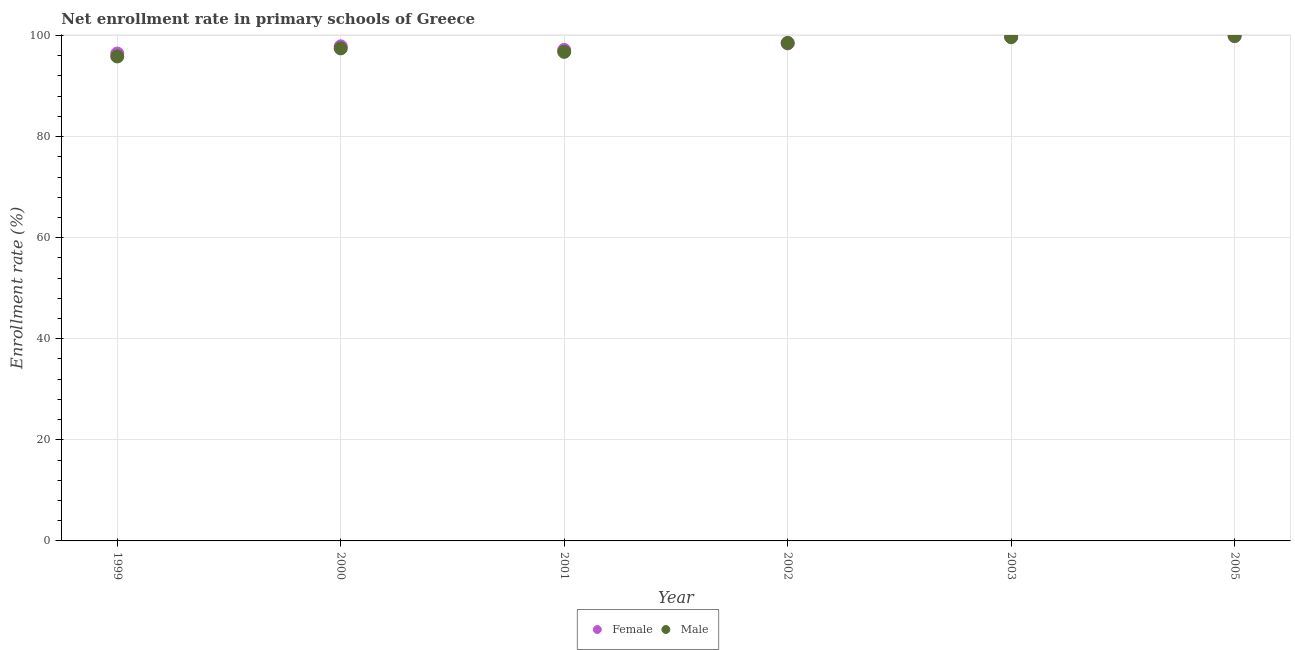Is the number of dotlines equal to the number of legend labels?
Offer a very short reply. Yes. What is the enrollment rate of female students in 2002?
Your answer should be very brief. 98.45. Across all years, what is the maximum enrollment rate of female students?
Offer a very short reply. 99.88. Across all years, what is the minimum enrollment rate of female students?
Offer a very short reply. 96.44. In which year was the enrollment rate of male students minimum?
Give a very brief answer. 1999. What is the total enrollment rate of male students in the graph?
Your answer should be very brief. 588.23. What is the difference between the enrollment rate of male students in 1999 and that in 2001?
Your answer should be very brief. -0.91. What is the difference between the enrollment rate of male students in 1999 and the enrollment rate of female students in 2002?
Offer a very short reply. -2.59. What is the average enrollment rate of male students per year?
Offer a very short reply. 98.04. In the year 2000, what is the difference between the enrollment rate of male students and enrollment rate of female students?
Your answer should be very brief. -0.41. In how many years, is the enrollment rate of female students greater than 32 %?
Ensure brevity in your answer.  6. What is the ratio of the enrollment rate of female students in 1999 to that in 2005?
Offer a terse response. 0.97. Is the enrollment rate of female students in 2001 less than that in 2005?
Ensure brevity in your answer.  Yes. What is the difference between the highest and the second highest enrollment rate of female students?
Make the answer very short. 0.11. What is the difference between the highest and the lowest enrollment rate of female students?
Give a very brief answer. 3.44. Is the enrollment rate of male students strictly greater than the enrollment rate of female students over the years?
Make the answer very short. No. Is the enrollment rate of male students strictly less than the enrollment rate of female students over the years?
Offer a very short reply. No. Does the graph contain grids?
Make the answer very short. Yes. Where does the legend appear in the graph?
Offer a very short reply. Bottom center. How are the legend labels stacked?
Offer a terse response. Horizontal. What is the title of the graph?
Ensure brevity in your answer.  Net enrollment rate in primary schools of Greece. What is the label or title of the X-axis?
Your answer should be very brief. Year. What is the label or title of the Y-axis?
Offer a terse response. Enrollment rate (%). What is the Enrollment rate (%) in Female in 1999?
Keep it short and to the point. 96.44. What is the Enrollment rate (%) in Male in 1999?
Your answer should be very brief. 95.86. What is the Enrollment rate (%) of Female in 2000?
Your answer should be very brief. 97.86. What is the Enrollment rate (%) of Male in 2000?
Keep it short and to the point. 97.46. What is the Enrollment rate (%) of Female in 2001?
Offer a very short reply. 97.15. What is the Enrollment rate (%) in Male in 2001?
Give a very brief answer. 96.77. What is the Enrollment rate (%) of Female in 2002?
Offer a terse response. 98.45. What is the Enrollment rate (%) in Male in 2002?
Make the answer very short. 98.54. What is the Enrollment rate (%) of Female in 2003?
Provide a short and direct response. 99.77. What is the Enrollment rate (%) of Male in 2003?
Give a very brief answer. 99.67. What is the Enrollment rate (%) of Female in 2005?
Offer a very short reply. 99.88. What is the Enrollment rate (%) in Male in 2005?
Your response must be concise. 99.93. Across all years, what is the maximum Enrollment rate (%) in Female?
Your answer should be compact. 99.88. Across all years, what is the maximum Enrollment rate (%) of Male?
Your response must be concise. 99.93. Across all years, what is the minimum Enrollment rate (%) in Female?
Your response must be concise. 96.44. Across all years, what is the minimum Enrollment rate (%) in Male?
Offer a terse response. 95.86. What is the total Enrollment rate (%) in Female in the graph?
Ensure brevity in your answer.  589.54. What is the total Enrollment rate (%) of Male in the graph?
Offer a terse response. 588.23. What is the difference between the Enrollment rate (%) of Female in 1999 and that in 2000?
Keep it short and to the point. -1.43. What is the difference between the Enrollment rate (%) of Male in 1999 and that in 2000?
Provide a succinct answer. -1.6. What is the difference between the Enrollment rate (%) in Female in 1999 and that in 2001?
Provide a succinct answer. -0.72. What is the difference between the Enrollment rate (%) in Male in 1999 and that in 2001?
Your response must be concise. -0.91. What is the difference between the Enrollment rate (%) in Female in 1999 and that in 2002?
Keep it short and to the point. -2.01. What is the difference between the Enrollment rate (%) of Male in 1999 and that in 2002?
Offer a terse response. -2.68. What is the difference between the Enrollment rate (%) of Female in 1999 and that in 2003?
Your answer should be compact. -3.33. What is the difference between the Enrollment rate (%) of Male in 1999 and that in 2003?
Your answer should be compact. -3.81. What is the difference between the Enrollment rate (%) of Female in 1999 and that in 2005?
Your answer should be very brief. -3.44. What is the difference between the Enrollment rate (%) of Male in 1999 and that in 2005?
Your answer should be very brief. -4.07. What is the difference between the Enrollment rate (%) of Female in 2000 and that in 2001?
Offer a terse response. 0.71. What is the difference between the Enrollment rate (%) of Male in 2000 and that in 2001?
Ensure brevity in your answer.  0.69. What is the difference between the Enrollment rate (%) of Female in 2000 and that in 2002?
Provide a short and direct response. -0.58. What is the difference between the Enrollment rate (%) of Male in 2000 and that in 2002?
Keep it short and to the point. -1.09. What is the difference between the Enrollment rate (%) in Female in 2000 and that in 2003?
Offer a very short reply. -1.91. What is the difference between the Enrollment rate (%) in Male in 2000 and that in 2003?
Offer a very short reply. -2.21. What is the difference between the Enrollment rate (%) in Female in 2000 and that in 2005?
Ensure brevity in your answer.  -2.01. What is the difference between the Enrollment rate (%) in Male in 2000 and that in 2005?
Keep it short and to the point. -2.47. What is the difference between the Enrollment rate (%) of Female in 2001 and that in 2002?
Keep it short and to the point. -1.3. What is the difference between the Enrollment rate (%) of Male in 2001 and that in 2002?
Your response must be concise. -1.77. What is the difference between the Enrollment rate (%) in Female in 2001 and that in 2003?
Provide a succinct answer. -2.62. What is the difference between the Enrollment rate (%) of Male in 2001 and that in 2003?
Provide a succinct answer. -2.9. What is the difference between the Enrollment rate (%) in Female in 2001 and that in 2005?
Give a very brief answer. -2.72. What is the difference between the Enrollment rate (%) of Male in 2001 and that in 2005?
Your answer should be very brief. -3.16. What is the difference between the Enrollment rate (%) of Female in 2002 and that in 2003?
Provide a short and direct response. -1.32. What is the difference between the Enrollment rate (%) of Male in 2002 and that in 2003?
Keep it short and to the point. -1.13. What is the difference between the Enrollment rate (%) in Female in 2002 and that in 2005?
Your response must be concise. -1.43. What is the difference between the Enrollment rate (%) of Male in 2002 and that in 2005?
Offer a very short reply. -1.38. What is the difference between the Enrollment rate (%) of Female in 2003 and that in 2005?
Offer a terse response. -0.11. What is the difference between the Enrollment rate (%) in Male in 2003 and that in 2005?
Make the answer very short. -0.26. What is the difference between the Enrollment rate (%) in Female in 1999 and the Enrollment rate (%) in Male in 2000?
Ensure brevity in your answer.  -1.02. What is the difference between the Enrollment rate (%) in Female in 1999 and the Enrollment rate (%) in Male in 2001?
Offer a very short reply. -0.34. What is the difference between the Enrollment rate (%) of Female in 1999 and the Enrollment rate (%) of Male in 2002?
Provide a short and direct response. -2.11. What is the difference between the Enrollment rate (%) in Female in 1999 and the Enrollment rate (%) in Male in 2003?
Offer a very short reply. -3.24. What is the difference between the Enrollment rate (%) of Female in 1999 and the Enrollment rate (%) of Male in 2005?
Provide a succinct answer. -3.49. What is the difference between the Enrollment rate (%) of Female in 2000 and the Enrollment rate (%) of Male in 2001?
Provide a succinct answer. 1.09. What is the difference between the Enrollment rate (%) in Female in 2000 and the Enrollment rate (%) in Male in 2002?
Your answer should be compact. -0.68. What is the difference between the Enrollment rate (%) in Female in 2000 and the Enrollment rate (%) in Male in 2003?
Ensure brevity in your answer.  -1.81. What is the difference between the Enrollment rate (%) in Female in 2000 and the Enrollment rate (%) in Male in 2005?
Provide a short and direct response. -2.06. What is the difference between the Enrollment rate (%) of Female in 2001 and the Enrollment rate (%) of Male in 2002?
Provide a succinct answer. -1.39. What is the difference between the Enrollment rate (%) of Female in 2001 and the Enrollment rate (%) of Male in 2003?
Keep it short and to the point. -2.52. What is the difference between the Enrollment rate (%) of Female in 2001 and the Enrollment rate (%) of Male in 2005?
Make the answer very short. -2.77. What is the difference between the Enrollment rate (%) of Female in 2002 and the Enrollment rate (%) of Male in 2003?
Give a very brief answer. -1.22. What is the difference between the Enrollment rate (%) of Female in 2002 and the Enrollment rate (%) of Male in 2005?
Provide a short and direct response. -1.48. What is the difference between the Enrollment rate (%) of Female in 2003 and the Enrollment rate (%) of Male in 2005?
Offer a very short reply. -0.16. What is the average Enrollment rate (%) in Female per year?
Provide a succinct answer. 98.26. What is the average Enrollment rate (%) in Male per year?
Offer a terse response. 98.04. In the year 1999, what is the difference between the Enrollment rate (%) in Female and Enrollment rate (%) in Male?
Provide a short and direct response. 0.57. In the year 2000, what is the difference between the Enrollment rate (%) in Female and Enrollment rate (%) in Male?
Make the answer very short. 0.41. In the year 2001, what is the difference between the Enrollment rate (%) in Female and Enrollment rate (%) in Male?
Make the answer very short. 0.38. In the year 2002, what is the difference between the Enrollment rate (%) of Female and Enrollment rate (%) of Male?
Your answer should be compact. -0.1. In the year 2003, what is the difference between the Enrollment rate (%) of Female and Enrollment rate (%) of Male?
Your response must be concise. 0.1. In the year 2005, what is the difference between the Enrollment rate (%) of Female and Enrollment rate (%) of Male?
Offer a terse response. -0.05. What is the ratio of the Enrollment rate (%) in Female in 1999 to that in 2000?
Offer a terse response. 0.99. What is the ratio of the Enrollment rate (%) of Male in 1999 to that in 2000?
Offer a terse response. 0.98. What is the ratio of the Enrollment rate (%) of Male in 1999 to that in 2001?
Keep it short and to the point. 0.99. What is the ratio of the Enrollment rate (%) of Female in 1999 to that in 2002?
Keep it short and to the point. 0.98. What is the ratio of the Enrollment rate (%) of Male in 1999 to that in 2002?
Provide a succinct answer. 0.97. What is the ratio of the Enrollment rate (%) of Female in 1999 to that in 2003?
Your answer should be compact. 0.97. What is the ratio of the Enrollment rate (%) in Male in 1999 to that in 2003?
Your response must be concise. 0.96. What is the ratio of the Enrollment rate (%) of Female in 1999 to that in 2005?
Provide a short and direct response. 0.97. What is the ratio of the Enrollment rate (%) in Male in 1999 to that in 2005?
Make the answer very short. 0.96. What is the ratio of the Enrollment rate (%) of Female in 2000 to that in 2001?
Your response must be concise. 1.01. What is the ratio of the Enrollment rate (%) of Male in 2000 to that in 2001?
Ensure brevity in your answer.  1.01. What is the ratio of the Enrollment rate (%) of Female in 2000 to that in 2002?
Make the answer very short. 0.99. What is the ratio of the Enrollment rate (%) of Male in 2000 to that in 2002?
Your response must be concise. 0.99. What is the ratio of the Enrollment rate (%) in Female in 2000 to that in 2003?
Ensure brevity in your answer.  0.98. What is the ratio of the Enrollment rate (%) of Male in 2000 to that in 2003?
Offer a terse response. 0.98. What is the ratio of the Enrollment rate (%) in Female in 2000 to that in 2005?
Your response must be concise. 0.98. What is the ratio of the Enrollment rate (%) of Male in 2000 to that in 2005?
Ensure brevity in your answer.  0.98. What is the ratio of the Enrollment rate (%) in Female in 2001 to that in 2003?
Your response must be concise. 0.97. What is the ratio of the Enrollment rate (%) of Male in 2001 to that in 2003?
Your answer should be compact. 0.97. What is the ratio of the Enrollment rate (%) in Female in 2001 to that in 2005?
Make the answer very short. 0.97. What is the ratio of the Enrollment rate (%) of Male in 2001 to that in 2005?
Your response must be concise. 0.97. What is the ratio of the Enrollment rate (%) of Male in 2002 to that in 2003?
Ensure brevity in your answer.  0.99. What is the ratio of the Enrollment rate (%) in Female in 2002 to that in 2005?
Provide a short and direct response. 0.99. What is the ratio of the Enrollment rate (%) in Male in 2002 to that in 2005?
Provide a short and direct response. 0.99. What is the ratio of the Enrollment rate (%) of Male in 2003 to that in 2005?
Keep it short and to the point. 1. What is the difference between the highest and the second highest Enrollment rate (%) in Female?
Offer a terse response. 0.11. What is the difference between the highest and the second highest Enrollment rate (%) in Male?
Offer a terse response. 0.26. What is the difference between the highest and the lowest Enrollment rate (%) of Female?
Make the answer very short. 3.44. What is the difference between the highest and the lowest Enrollment rate (%) of Male?
Give a very brief answer. 4.07. 